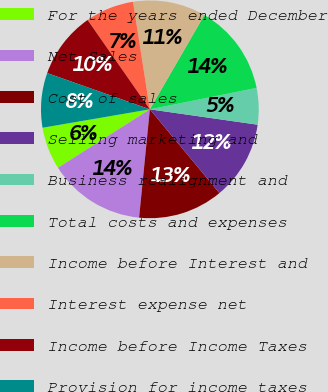Convert chart to OTSL. <chart><loc_0><loc_0><loc_500><loc_500><pie_chart><fcel>For the years ended December<fcel>Net Sales<fcel>Cost of sales<fcel>Selling marketing and<fcel>Business realignment and<fcel>Total costs and expenses<fcel>Income before Interest and<fcel>Interest expense net<fcel>Income before Income Taxes<fcel>Provision for income taxes<nl><fcel>6.31%<fcel>14.41%<fcel>12.61%<fcel>11.71%<fcel>5.41%<fcel>13.51%<fcel>10.81%<fcel>7.21%<fcel>9.91%<fcel>8.11%<nl></chart> 